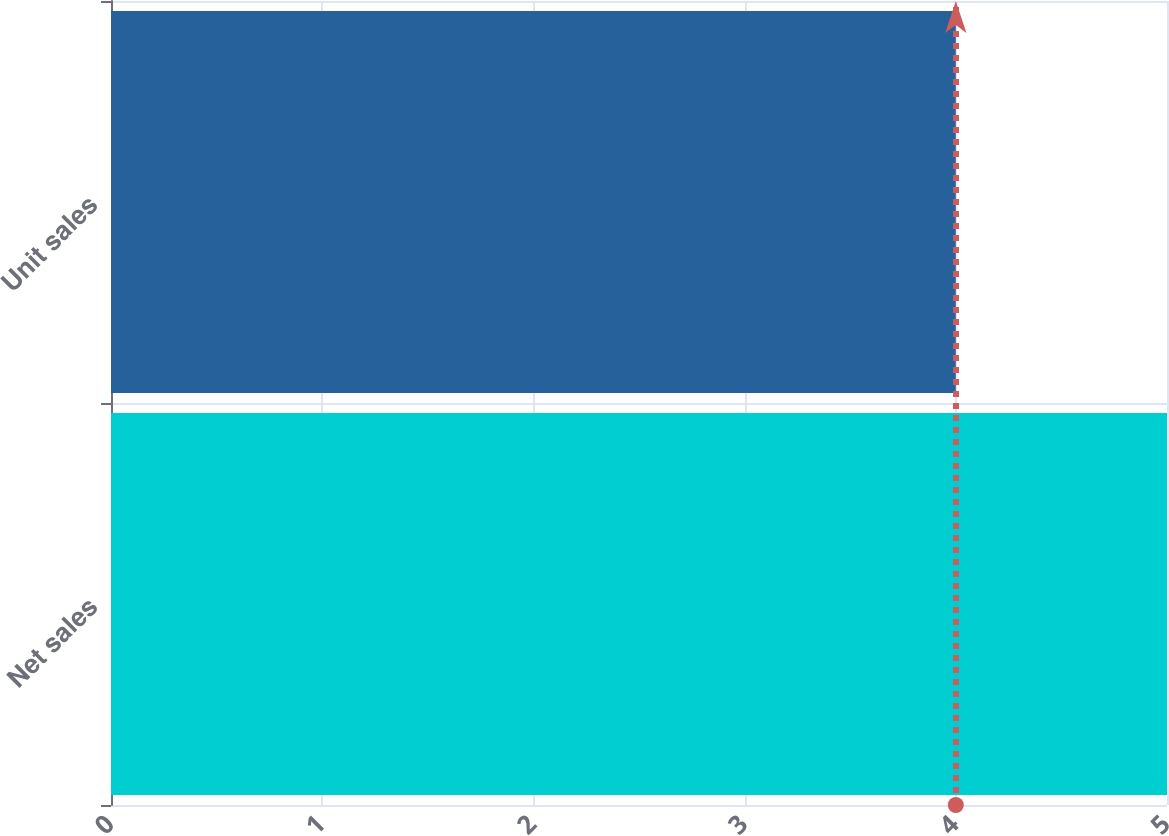<chart> <loc_0><loc_0><loc_500><loc_500><bar_chart><fcel>Net sales<fcel>Unit sales<nl><fcel>5<fcel>4<nl></chart> 